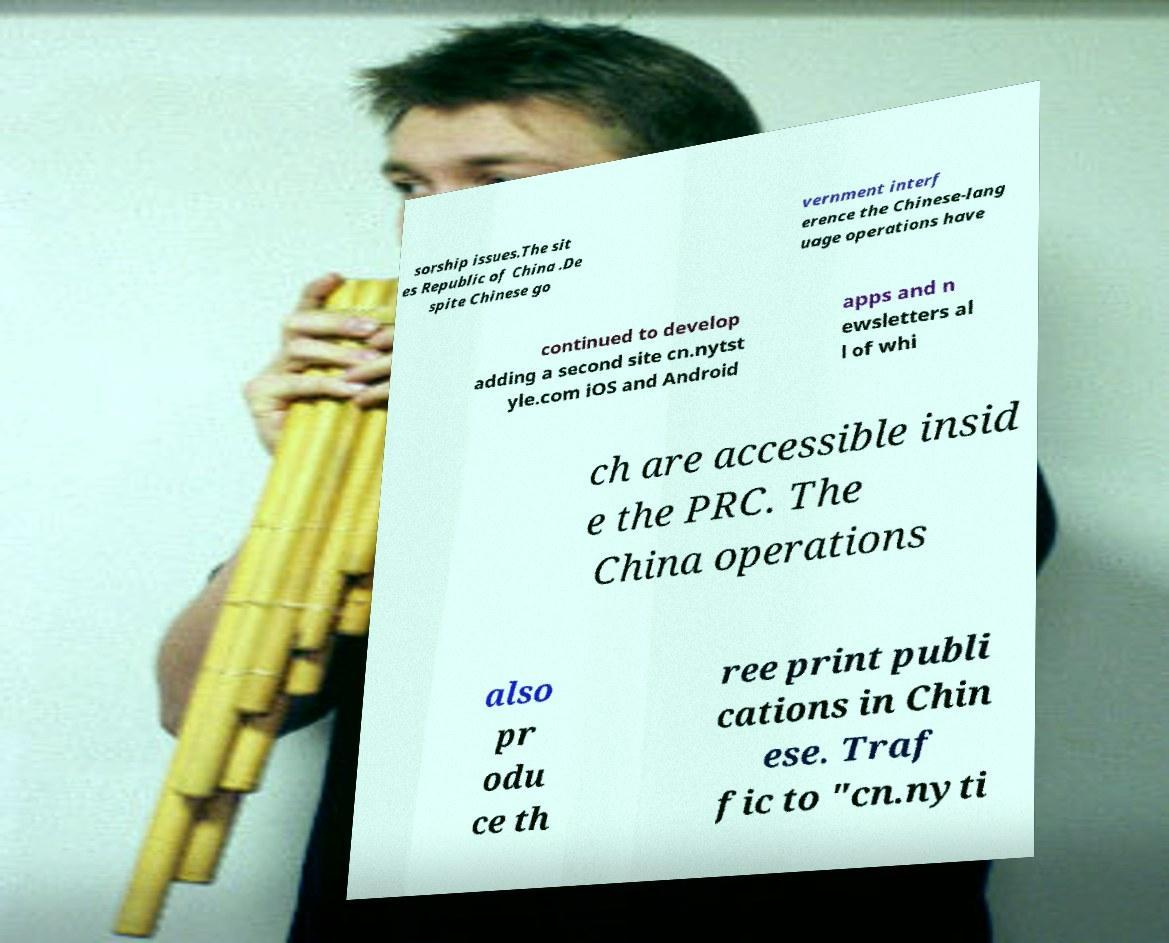Please identify and transcribe the text found in this image. sorship issues.The sit es Republic of China .De spite Chinese go vernment interf erence the Chinese-lang uage operations have continued to develop adding a second site cn.nytst yle.com iOS and Android apps and n ewsletters al l of whi ch are accessible insid e the PRC. The China operations also pr odu ce th ree print publi cations in Chin ese. Traf fic to "cn.nyti 